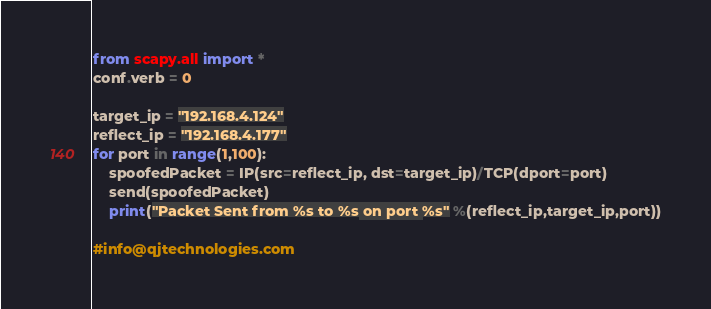Convert code to text. <code><loc_0><loc_0><loc_500><loc_500><_Python_>from scapy.all import *
conf.verb = 0

target_ip = "192.168.4.124"
reflect_ip = "192.168.4.177"
for port in range(1,100):
    spoofedPacket = IP(src=reflect_ip, dst=target_ip)/TCP(dport=port)
    send(spoofedPacket)
    print("Packet Sent from %s to %s on port %s" %(reflect_ip,target_ip,port))

#info@qjtechnologies.com</code> 